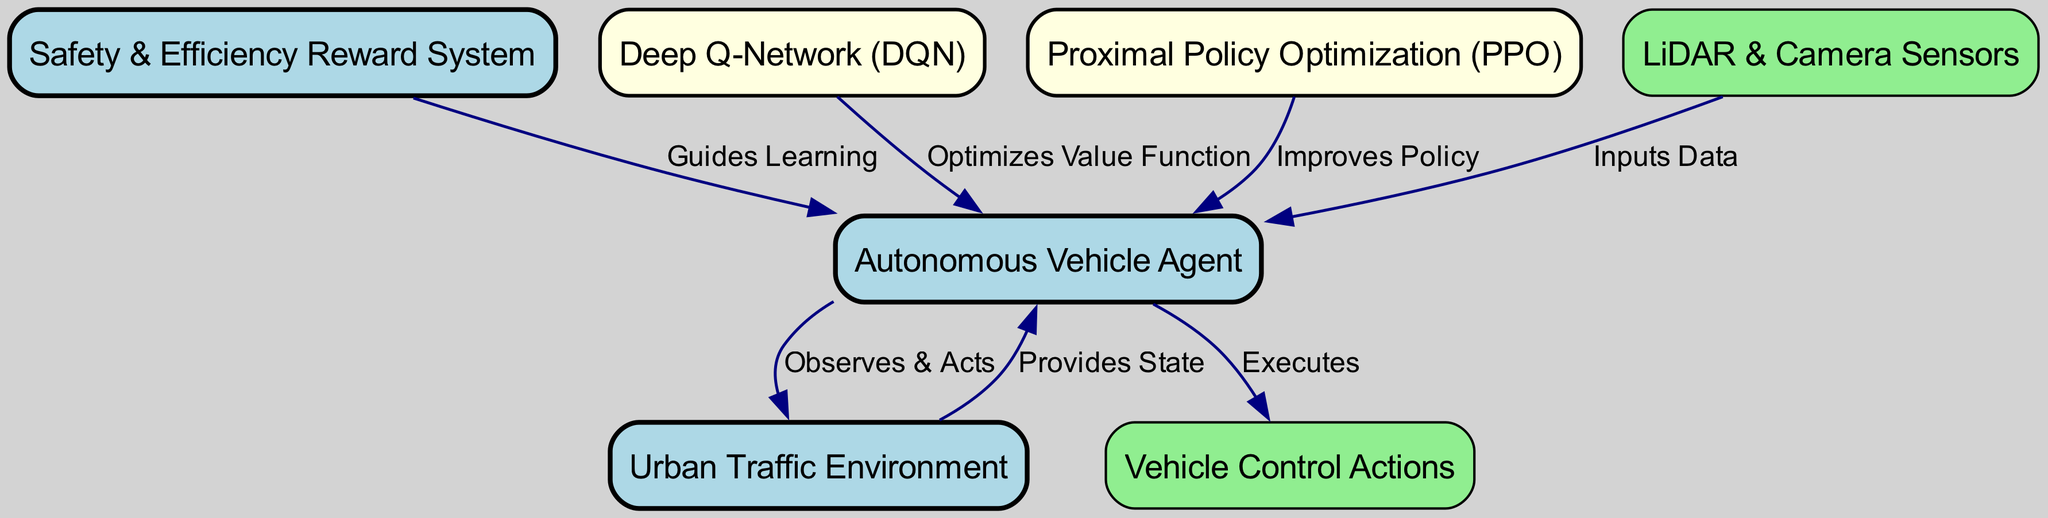What is the total number of nodes in the diagram? The diagram contains six distinct nodes: the agent, environment, reward, deep Q-network, proximal policy optimization, and sensors. Counting these gives a total of six nodes.
Answer: Six Which node acts as the input provider for the agent? The "LiDAR & Camera Sensors" node provides input data directly to the agent, as indicated by the edge that connects the sensors to the agent.
Answer: LiDAR & Camera Sensors How does the environment interact with the agent? The environment provides the state to the agent, as shown in the directed edge labeled "Provides State" connecting the environment to the agent.
Answer: Provides State What are the reward systems connected to the agent? The diagram specifies a "Safety & Efficiency Reward System" that guides the learning of the agent, as indicated by the edge pointing from the reward node to the agent.
Answer: Safety & Efficiency Reward System Which algorithm optimizes the value function for the agent? The Deep Q-Network (DQN) is responsible for optimizing the value function of the agent, as indicated by the corresponding edge pointing to the agent.
Answer: Deep Q-Network What actions does the agent execute? The agent executes "Vehicle Control Actions" as denoted by the directed edge from the agent node to the actions node.
Answer: Vehicle Control Actions What type of learning does the Proximal Policy Optimization (PPO) algorithm support? The PPO algorithm improves the policy of the agent, as indicated by the labeled edge connecting PPO to the agent.
Answer: Improves Policy How many edges connect the environment to the agent? There are two edges connecting the environment to the agent: one providing the state and another in the context of observing and acting. Therefore, there are two edges.
Answer: Two What do the sensors provide to the agent? The sensors provide input data to the agent, as indicated by the outgoing edge from the sensors node to the agent node labeled "Inputs Data."
Answer: Input Data 